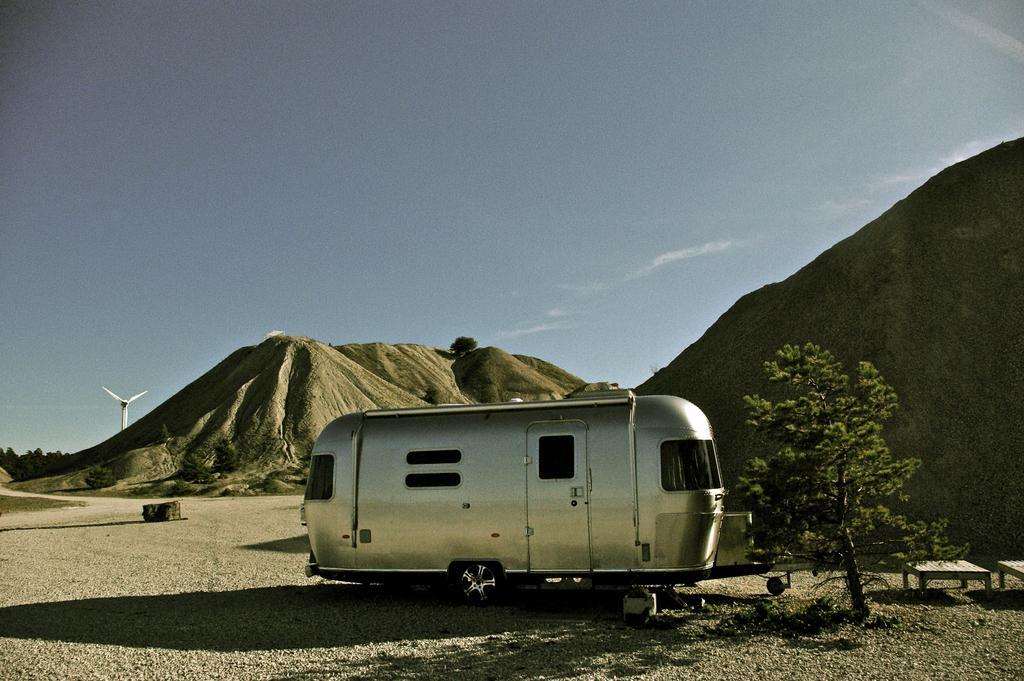In one or two sentences, can you explain what this image depicts? In this image in the center there is one vehicle, and at the bottom there is sand on the right side there is one tree and some benches. In the background there are some mountains and a fan, on the top of the image there is sky. 